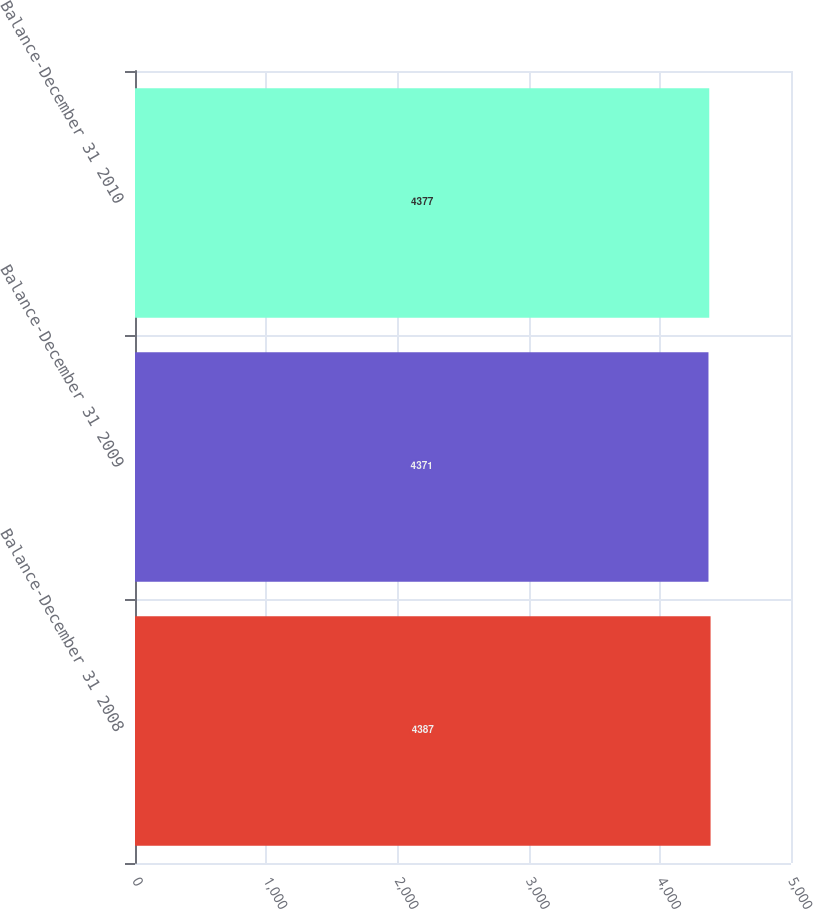Convert chart. <chart><loc_0><loc_0><loc_500><loc_500><bar_chart><fcel>Balance-December 31 2008<fcel>Balance-December 31 2009<fcel>Balance-December 31 2010<nl><fcel>4387<fcel>4371<fcel>4377<nl></chart> 